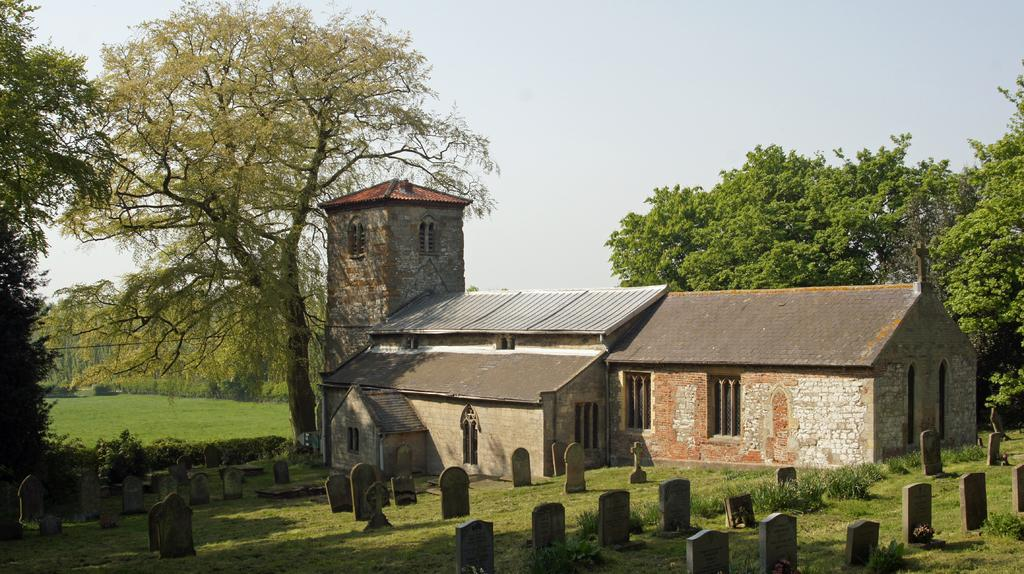What type of structures can be seen in the image? There are houses in the image. What other natural elements are present in the image? There are trees in the image. What part of the houses can be seen in the image? There are windows visible in the image. What type of location can be seen in the image? There is a cemetery in the image. What is the color of the sky in the image? The sky is blue and white in color. Can you tell me how many dogs are playing in the cemetery in the image? There are no dogs present in the image; it only features houses, trees, windows, and a cemetery. 